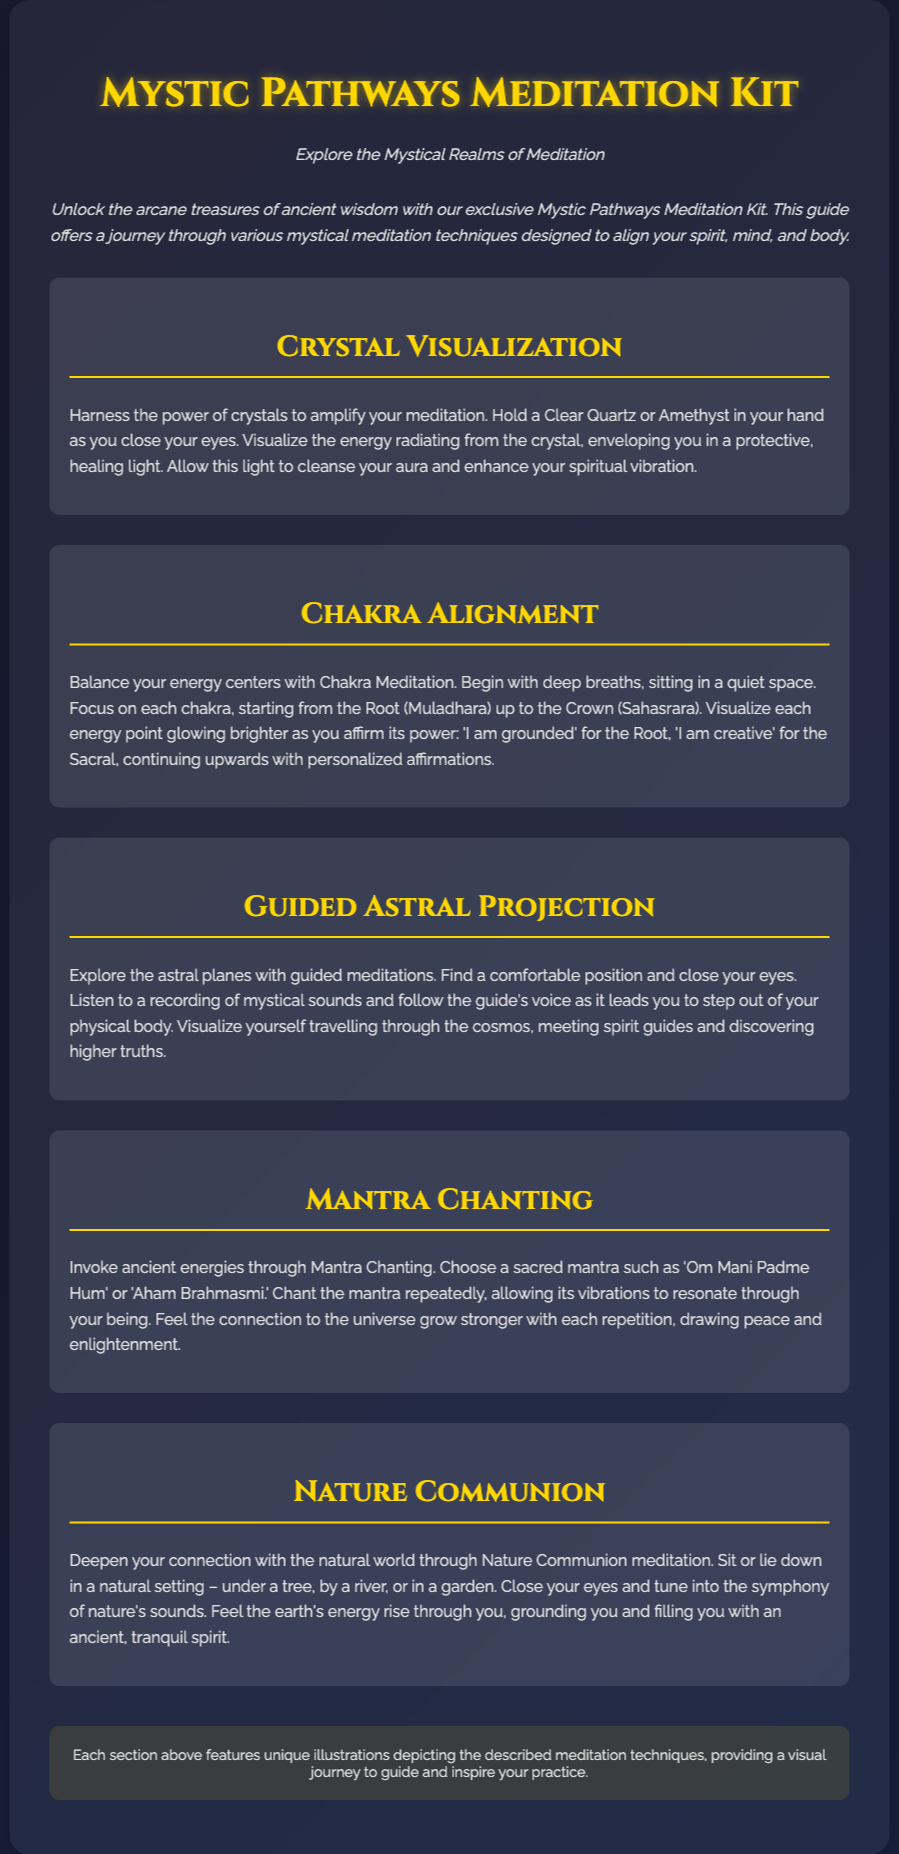What is the title of the meditation kit? The title is prominently displayed at the top of the document, which is "Mystic Pathways Meditation Kit."
Answer: Mystic Pathways Meditation Kit How many mystical meditation techniques are described in the document? The document features five distinct mystical meditation techniques, each in its own section.
Answer: Five What is the first meditation technique mentioned? The first technique listed in the document is "Crystal Visualization."
Answer: Crystal Visualization What sacred mantra is suggested for chanting? The document mentions "Om Mani Padme Hum" as a suggested sacred mantra.
Answer: Om Mani Padme Hum What setting is recommended for Nature Communion meditation? The document suggests being in a natural setting such as under a tree, by a river, or in a garden for this meditation.
Answer: Natural setting What visual aid accompanies each meditation technique? Each section features unique illustrations that depict the meditation techniques described.
Answer: Unique illustrations 